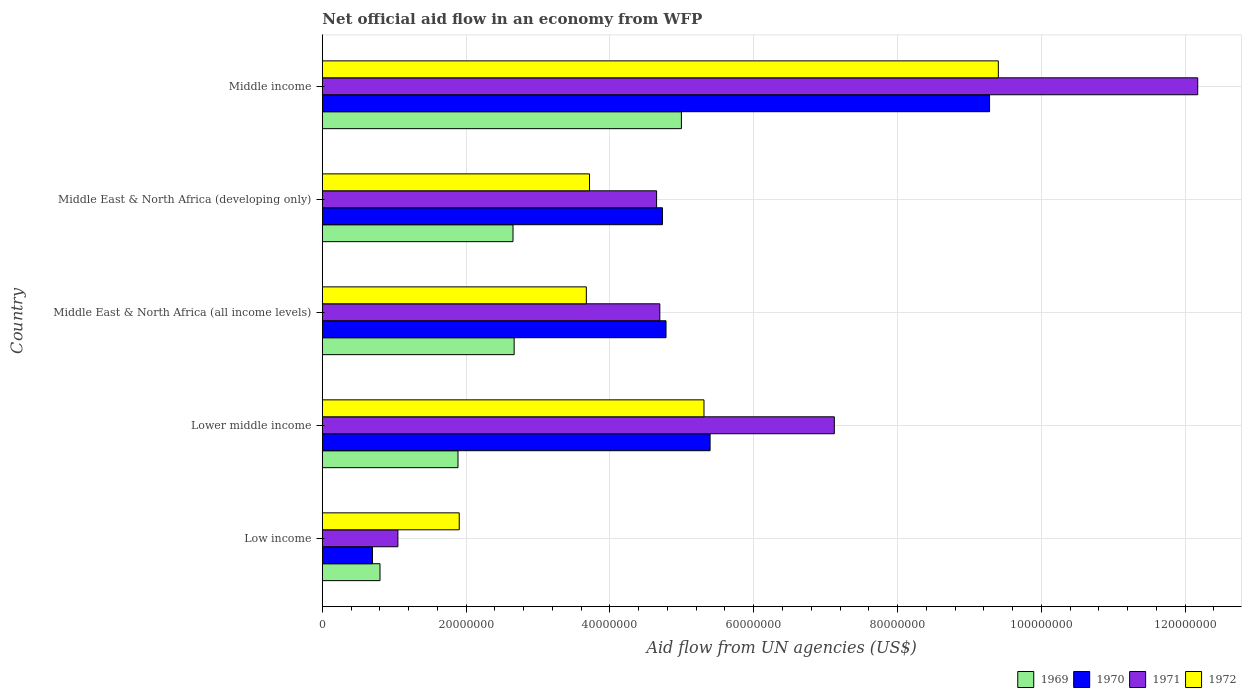How many different coloured bars are there?
Ensure brevity in your answer.  4. Are the number of bars per tick equal to the number of legend labels?
Your response must be concise. Yes. Are the number of bars on each tick of the Y-axis equal?
Provide a short and direct response. Yes. How many bars are there on the 5th tick from the top?
Make the answer very short. 4. How many bars are there on the 4th tick from the bottom?
Give a very brief answer. 4. What is the label of the 1st group of bars from the top?
Your response must be concise. Middle income. In how many cases, is the number of bars for a given country not equal to the number of legend labels?
Keep it short and to the point. 0. What is the net official aid flow in 1972 in Middle income?
Your answer should be compact. 9.40e+07. Across all countries, what is the maximum net official aid flow in 1972?
Give a very brief answer. 9.40e+07. Across all countries, what is the minimum net official aid flow in 1972?
Your answer should be compact. 1.90e+07. In which country was the net official aid flow in 1971 maximum?
Your response must be concise. Middle income. What is the total net official aid flow in 1971 in the graph?
Give a very brief answer. 2.97e+08. What is the difference between the net official aid flow in 1970 in Middle East & North Africa (all income levels) and that in Middle income?
Provide a short and direct response. -4.50e+07. What is the difference between the net official aid flow in 1969 in Middle East & North Africa (all income levels) and the net official aid flow in 1972 in Low income?
Your answer should be compact. 7.64e+06. What is the average net official aid flow in 1969 per country?
Ensure brevity in your answer.  2.60e+07. What is the difference between the net official aid flow in 1971 and net official aid flow in 1972 in Middle East & North Africa (developing only)?
Your answer should be very brief. 9.33e+06. What is the ratio of the net official aid flow in 1971 in Middle East & North Africa (all income levels) to that in Middle income?
Keep it short and to the point. 0.39. Is the net official aid flow in 1972 in Low income less than that in Middle income?
Provide a short and direct response. Yes. Is the difference between the net official aid flow in 1971 in Lower middle income and Middle East & North Africa (all income levels) greater than the difference between the net official aid flow in 1972 in Lower middle income and Middle East & North Africa (all income levels)?
Offer a terse response. Yes. What is the difference between the highest and the second highest net official aid flow in 1972?
Your answer should be compact. 4.09e+07. What is the difference between the highest and the lowest net official aid flow in 1971?
Provide a short and direct response. 1.11e+08. Is it the case that in every country, the sum of the net official aid flow in 1969 and net official aid flow in 1972 is greater than the sum of net official aid flow in 1971 and net official aid flow in 1970?
Offer a very short reply. No. How many bars are there?
Your answer should be compact. 20. What is the difference between two consecutive major ticks on the X-axis?
Give a very brief answer. 2.00e+07. Does the graph contain any zero values?
Give a very brief answer. No. Where does the legend appear in the graph?
Make the answer very short. Bottom right. How are the legend labels stacked?
Provide a short and direct response. Horizontal. What is the title of the graph?
Your answer should be very brief. Net official aid flow in an economy from WFP. What is the label or title of the X-axis?
Offer a very short reply. Aid flow from UN agencies (US$). What is the Aid flow from UN agencies (US$) of 1969 in Low income?
Your answer should be compact. 8.02e+06. What is the Aid flow from UN agencies (US$) in 1970 in Low income?
Your answer should be very brief. 6.97e+06. What is the Aid flow from UN agencies (US$) of 1971 in Low income?
Ensure brevity in your answer.  1.05e+07. What is the Aid flow from UN agencies (US$) of 1972 in Low income?
Keep it short and to the point. 1.90e+07. What is the Aid flow from UN agencies (US$) in 1969 in Lower middle income?
Give a very brief answer. 1.89e+07. What is the Aid flow from UN agencies (US$) in 1970 in Lower middle income?
Your answer should be very brief. 5.39e+07. What is the Aid flow from UN agencies (US$) in 1971 in Lower middle income?
Your answer should be compact. 7.12e+07. What is the Aid flow from UN agencies (US$) of 1972 in Lower middle income?
Offer a terse response. 5.31e+07. What is the Aid flow from UN agencies (US$) in 1969 in Middle East & North Africa (all income levels)?
Offer a terse response. 2.67e+07. What is the Aid flow from UN agencies (US$) in 1970 in Middle East & North Africa (all income levels)?
Make the answer very short. 4.78e+07. What is the Aid flow from UN agencies (US$) of 1971 in Middle East & North Africa (all income levels)?
Keep it short and to the point. 4.69e+07. What is the Aid flow from UN agencies (US$) of 1972 in Middle East & North Africa (all income levels)?
Keep it short and to the point. 3.67e+07. What is the Aid flow from UN agencies (US$) of 1969 in Middle East & North Africa (developing only)?
Your answer should be compact. 2.65e+07. What is the Aid flow from UN agencies (US$) of 1970 in Middle East & North Africa (developing only)?
Offer a terse response. 4.73e+07. What is the Aid flow from UN agencies (US$) in 1971 in Middle East & North Africa (developing only)?
Make the answer very short. 4.65e+07. What is the Aid flow from UN agencies (US$) in 1972 in Middle East & North Africa (developing only)?
Ensure brevity in your answer.  3.72e+07. What is the Aid flow from UN agencies (US$) in 1969 in Middle income?
Ensure brevity in your answer.  4.99e+07. What is the Aid flow from UN agencies (US$) in 1970 in Middle income?
Your response must be concise. 9.28e+07. What is the Aid flow from UN agencies (US$) of 1971 in Middle income?
Provide a succinct answer. 1.22e+08. What is the Aid flow from UN agencies (US$) of 1972 in Middle income?
Make the answer very short. 9.40e+07. Across all countries, what is the maximum Aid flow from UN agencies (US$) of 1969?
Your answer should be very brief. 4.99e+07. Across all countries, what is the maximum Aid flow from UN agencies (US$) in 1970?
Offer a very short reply. 9.28e+07. Across all countries, what is the maximum Aid flow from UN agencies (US$) in 1971?
Make the answer very short. 1.22e+08. Across all countries, what is the maximum Aid flow from UN agencies (US$) of 1972?
Offer a very short reply. 9.40e+07. Across all countries, what is the minimum Aid flow from UN agencies (US$) in 1969?
Your answer should be compact. 8.02e+06. Across all countries, what is the minimum Aid flow from UN agencies (US$) of 1970?
Your answer should be compact. 6.97e+06. Across all countries, what is the minimum Aid flow from UN agencies (US$) in 1971?
Provide a succinct answer. 1.05e+07. Across all countries, what is the minimum Aid flow from UN agencies (US$) in 1972?
Your response must be concise. 1.90e+07. What is the total Aid flow from UN agencies (US$) of 1969 in the graph?
Provide a succinct answer. 1.30e+08. What is the total Aid flow from UN agencies (US$) in 1970 in the graph?
Keep it short and to the point. 2.49e+08. What is the total Aid flow from UN agencies (US$) in 1971 in the graph?
Your answer should be compact. 2.97e+08. What is the total Aid flow from UN agencies (US$) of 1972 in the graph?
Provide a short and direct response. 2.40e+08. What is the difference between the Aid flow from UN agencies (US$) in 1969 in Low income and that in Lower middle income?
Give a very brief answer. -1.08e+07. What is the difference between the Aid flow from UN agencies (US$) of 1970 in Low income and that in Lower middle income?
Make the answer very short. -4.70e+07. What is the difference between the Aid flow from UN agencies (US$) of 1971 in Low income and that in Lower middle income?
Ensure brevity in your answer.  -6.07e+07. What is the difference between the Aid flow from UN agencies (US$) in 1972 in Low income and that in Lower middle income?
Your response must be concise. -3.40e+07. What is the difference between the Aid flow from UN agencies (US$) of 1969 in Low income and that in Middle East & North Africa (all income levels)?
Keep it short and to the point. -1.87e+07. What is the difference between the Aid flow from UN agencies (US$) in 1970 in Low income and that in Middle East & North Africa (all income levels)?
Give a very brief answer. -4.08e+07. What is the difference between the Aid flow from UN agencies (US$) of 1971 in Low income and that in Middle East & North Africa (all income levels)?
Your answer should be very brief. -3.64e+07. What is the difference between the Aid flow from UN agencies (US$) in 1972 in Low income and that in Middle East & North Africa (all income levels)?
Provide a succinct answer. -1.77e+07. What is the difference between the Aid flow from UN agencies (US$) in 1969 in Low income and that in Middle East & North Africa (developing only)?
Make the answer very short. -1.85e+07. What is the difference between the Aid flow from UN agencies (US$) of 1970 in Low income and that in Middle East & North Africa (developing only)?
Your answer should be very brief. -4.03e+07. What is the difference between the Aid flow from UN agencies (US$) of 1971 in Low income and that in Middle East & North Africa (developing only)?
Provide a succinct answer. -3.60e+07. What is the difference between the Aid flow from UN agencies (US$) of 1972 in Low income and that in Middle East & North Africa (developing only)?
Your answer should be very brief. -1.81e+07. What is the difference between the Aid flow from UN agencies (US$) in 1969 in Low income and that in Middle income?
Your answer should be very brief. -4.19e+07. What is the difference between the Aid flow from UN agencies (US$) in 1970 in Low income and that in Middle income?
Ensure brevity in your answer.  -8.58e+07. What is the difference between the Aid flow from UN agencies (US$) of 1971 in Low income and that in Middle income?
Offer a terse response. -1.11e+08. What is the difference between the Aid flow from UN agencies (US$) in 1972 in Low income and that in Middle income?
Provide a succinct answer. -7.50e+07. What is the difference between the Aid flow from UN agencies (US$) in 1969 in Lower middle income and that in Middle East & North Africa (all income levels)?
Offer a terse response. -7.81e+06. What is the difference between the Aid flow from UN agencies (US$) in 1970 in Lower middle income and that in Middle East & North Africa (all income levels)?
Your response must be concise. 6.13e+06. What is the difference between the Aid flow from UN agencies (US$) of 1971 in Lower middle income and that in Middle East & North Africa (all income levels)?
Your answer should be very brief. 2.43e+07. What is the difference between the Aid flow from UN agencies (US$) of 1972 in Lower middle income and that in Middle East & North Africa (all income levels)?
Provide a short and direct response. 1.64e+07. What is the difference between the Aid flow from UN agencies (US$) in 1969 in Lower middle income and that in Middle East & North Africa (developing only)?
Give a very brief answer. -7.65e+06. What is the difference between the Aid flow from UN agencies (US$) in 1970 in Lower middle income and that in Middle East & North Africa (developing only)?
Keep it short and to the point. 6.63e+06. What is the difference between the Aid flow from UN agencies (US$) in 1971 in Lower middle income and that in Middle East & North Africa (developing only)?
Offer a very short reply. 2.47e+07. What is the difference between the Aid flow from UN agencies (US$) in 1972 in Lower middle income and that in Middle East & North Africa (developing only)?
Ensure brevity in your answer.  1.59e+07. What is the difference between the Aid flow from UN agencies (US$) of 1969 in Lower middle income and that in Middle income?
Give a very brief answer. -3.11e+07. What is the difference between the Aid flow from UN agencies (US$) in 1970 in Lower middle income and that in Middle income?
Your answer should be very brief. -3.89e+07. What is the difference between the Aid flow from UN agencies (US$) in 1971 in Lower middle income and that in Middle income?
Make the answer very short. -5.05e+07. What is the difference between the Aid flow from UN agencies (US$) of 1972 in Lower middle income and that in Middle income?
Keep it short and to the point. -4.09e+07. What is the difference between the Aid flow from UN agencies (US$) of 1972 in Middle East & North Africa (all income levels) and that in Middle East & North Africa (developing only)?
Your answer should be compact. -4.40e+05. What is the difference between the Aid flow from UN agencies (US$) of 1969 in Middle East & North Africa (all income levels) and that in Middle income?
Keep it short and to the point. -2.33e+07. What is the difference between the Aid flow from UN agencies (US$) in 1970 in Middle East & North Africa (all income levels) and that in Middle income?
Provide a succinct answer. -4.50e+07. What is the difference between the Aid flow from UN agencies (US$) in 1971 in Middle East & North Africa (all income levels) and that in Middle income?
Your answer should be very brief. -7.48e+07. What is the difference between the Aid flow from UN agencies (US$) in 1972 in Middle East & North Africa (all income levels) and that in Middle income?
Keep it short and to the point. -5.73e+07. What is the difference between the Aid flow from UN agencies (US$) of 1969 in Middle East & North Africa (developing only) and that in Middle income?
Provide a succinct answer. -2.34e+07. What is the difference between the Aid flow from UN agencies (US$) in 1970 in Middle East & North Africa (developing only) and that in Middle income?
Your response must be concise. -4.55e+07. What is the difference between the Aid flow from UN agencies (US$) in 1971 in Middle East & North Africa (developing only) and that in Middle income?
Your response must be concise. -7.53e+07. What is the difference between the Aid flow from UN agencies (US$) of 1972 in Middle East & North Africa (developing only) and that in Middle income?
Ensure brevity in your answer.  -5.69e+07. What is the difference between the Aid flow from UN agencies (US$) in 1969 in Low income and the Aid flow from UN agencies (US$) in 1970 in Lower middle income?
Your response must be concise. -4.59e+07. What is the difference between the Aid flow from UN agencies (US$) of 1969 in Low income and the Aid flow from UN agencies (US$) of 1971 in Lower middle income?
Ensure brevity in your answer.  -6.32e+07. What is the difference between the Aid flow from UN agencies (US$) in 1969 in Low income and the Aid flow from UN agencies (US$) in 1972 in Lower middle income?
Offer a terse response. -4.51e+07. What is the difference between the Aid flow from UN agencies (US$) of 1970 in Low income and the Aid flow from UN agencies (US$) of 1971 in Lower middle income?
Offer a very short reply. -6.42e+07. What is the difference between the Aid flow from UN agencies (US$) of 1970 in Low income and the Aid flow from UN agencies (US$) of 1972 in Lower middle income?
Make the answer very short. -4.61e+07. What is the difference between the Aid flow from UN agencies (US$) of 1971 in Low income and the Aid flow from UN agencies (US$) of 1972 in Lower middle income?
Offer a terse response. -4.26e+07. What is the difference between the Aid flow from UN agencies (US$) of 1969 in Low income and the Aid flow from UN agencies (US$) of 1970 in Middle East & North Africa (all income levels)?
Keep it short and to the point. -3.98e+07. What is the difference between the Aid flow from UN agencies (US$) in 1969 in Low income and the Aid flow from UN agencies (US$) in 1971 in Middle East & North Africa (all income levels)?
Offer a very short reply. -3.89e+07. What is the difference between the Aid flow from UN agencies (US$) of 1969 in Low income and the Aid flow from UN agencies (US$) of 1972 in Middle East & North Africa (all income levels)?
Your answer should be very brief. -2.87e+07. What is the difference between the Aid flow from UN agencies (US$) of 1970 in Low income and the Aid flow from UN agencies (US$) of 1971 in Middle East & North Africa (all income levels)?
Provide a short and direct response. -4.00e+07. What is the difference between the Aid flow from UN agencies (US$) in 1970 in Low income and the Aid flow from UN agencies (US$) in 1972 in Middle East & North Africa (all income levels)?
Provide a succinct answer. -2.98e+07. What is the difference between the Aid flow from UN agencies (US$) in 1971 in Low income and the Aid flow from UN agencies (US$) in 1972 in Middle East & North Africa (all income levels)?
Give a very brief answer. -2.62e+07. What is the difference between the Aid flow from UN agencies (US$) in 1969 in Low income and the Aid flow from UN agencies (US$) in 1970 in Middle East & North Africa (developing only)?
Ensure brevity in your answer.  -3.93e+07. What is the difference between the Aid flow from UN agencies (US$) in 1969 in Low income and the Aid flow from UN agencies (US$) in 1971 in Middle East & North Africa (developing only)?
Keep it short and to the point. -3.85e+07. What is the difference between the Aid flow from UN agencies (US$) in 1969 in Low income and the Aid flow from UN agencies (US$) in 1972 in Middle East & North Africa (developing only)?
Offer a very short reply. -2.91e+07. What is the difference between the Aid flow from UN agencies (US$) in 1970 in Low income and the Aid flow from UN agencies (US$) in 1971 in Middle East & North Africa (developing only)?
Your response must be concise. -3.95e+07. What is the difference between the Aid flow from UN agencies (US$) of 1970 in Low income and the Aid flow from UN agencies (US$) of 1972 in Middle East & North Africa (developing only)?
Provide a succinct answer. -3.02e+07. What is the difference between the Aid flow from UN agencies (US$) of 1971 in Low income and the Aid flow from UN agencies (US$) of 1972 in Middle East & North Africa (developing only)?
Ensure brevity in your answer.  -2.66e+07. What is the difference between the Aid flow from UN agencies (US$) of 1969 in Low income and the Aid flow from UN agencies (US$) of 1970 in Middle income?
Offer a very short reply. -8.48e+07. What is the difference between the Aid flow from UN agencies (US$) of 1969 in Low income and the Aid flow from UN agencies (US$) of 1971 in Middle income?
Your answer should be very brief. -1.14e+08. What is the difference between the Aid flow from UN agencies (US$) of 1969 in Low income and the Aid flow from UN agencies (US$) of 1972 in Middle income?
Make the answer very short. -8.60e+07. What is the difference between the Aid flow from UN agencies (US$) in 1970 in Low income and the Aid flow from UN agencies (US$) in 1971 in Middle income?
Offer a terse response. -1.15e+08. What is the difference between the Aid flow from UN agencies (US$) of 1970 in Low income and the Aid flow from UN agencies (US$) of 1972 in Middle income?
Your answer should be very brief. -8.70e+07. What is the difference between the Aid flow from UN agencies (US$) in 1971 in Low income and the Aid flow from UN agencies (US$) in 1972 in Middle income?
Offer a terse response. -8.35e+07. What is the difference between the Aid flow from UN agencies (US$) of 1969 in Lower middle income and the Aid flow from UN agencies (US$) of 1970 in Middle East & North Africa (all income levels)?
Offer a terse response. -2.89e+07. What is the difference between the Aid flow from UN agencies (US$) of 1969 in Lower middle income and the Aid flow from UN agencies (US$) of 1971 in Middle East & North Africa (all income levels)?
Provide a short and direct response. -2.81e+07. What is the difference between the Aid flow from UN agencies (US$) of 1969 in Lower middle income and the Aid flow from UN agencies (US$) of 1972 in Middle East & North Africa (all income levels)?
Keep it short and to the point. -1.78e+07. What is the difference between the Aid flow from UN agencies (US$) in 1970 in Lower middle income and the Aid flow from UN agencies (US$) in 1971 in Middle East & North Africa (all income levels)?
Your answer should be very brief. 6.99e+06. What is the difference between the Aid flow from UN agencies (US$) of 1970 in Lower middle income and the Aid flow from UN agencies (US$) of 1972 in Middle East & North Africa (all income levels)?
Offer a very short reply. 1.72e+07. What is the difference between the Aid flow from UN agencies (US$) of 1971 in Lower middle income and the Aid flow from UN agencies (US$) of 1972 in Middle East & North Africa (all income levels)?
Offer a very short reply. 3.45e+07. What is the difference between the Aid flow from UN agencies (US$) in 1969 in Lower middle income and the Aid flow from UN agencies (US$) in 1970 in Middle East & North Africa (developing only)?
Your answer should be compact. -2.84e+07. What is the difference between the Aid flow from UN agencies (US$) in 1969 in Lower middle income and the Aid flow from UN agencies (US$) in 1971 in Middle East & North Africa (developing only)?
Ensure brevity in your answer.  -2.76e+07. What is the difference between the Aid flow from UN agencies (US$) in 1969 in Lower middle income and the Aid flow from UN agencies (US$) in 1972 in Middle East & North Africa (developing only)?
Your response must be concise. -1.83e+07. What is the difference between the Aid flow from UN agencies (US$) in 1970 in Lower middle income and the Aid flow from UN agencies (US$) in 1971 in Middle East & North Africa (developing only)?
Your answer should be compact. 7.44e+06. What is the difference between the Aid flow from UN agencies (US$) of 1970 in Lower middle income and the Aid flow from UN agencies (US$) of 1972 in Middle East & North Africa (developing only)?
Keep it short and to the point. 1.68e+07. What is the difference between the Aid flow from UN agencies (US$) in 1971 in Lower middle income and the Aid flow from UN agencies (US$) in 1972 in Middle East & North Africa (developing only)?
Ensure brevity in your answer.  3.40e+07. What is the difference between the Aid flow from UN agencies (US$) of 1969 in Lower middle income and the Aid flow from UN agencies (US$) of 1970 in Middle income?
Ensure brevity in your answer.  -7.39e+07. What is the difference between the Aid flow from UN agencies (US$) of 1969 in Lower middle income and the Aid flow from UN agencies (US$) of 1971 in Middle income?
Ensure brevity in your answer.  -1.03e+08. What is the difference between the Aid flow from UN agencies (US$) in 1969 in Lower middle income and the Aid flow from UN agencies (US$) in 1972 in Middle income?
Keep it short and to the point. -7.52e+07. What is the difference between the Aid flow from UN agencies (US$) of 1970 in Lower middle income and the Aid flow from UN agencies (US$) of 1971 in Middle income?
Provide a short and direct response. -6.78e+07. What is the difference between the Aid flow from UN agencies (US$) of 1970 in Lower middle income and the Aid flow from UN agencies (US$) of 1972 in Middle income?
Offer a very short reply. -4.01e+07. What is the difference between the Aid flow from UN agencies (US$) of 1971 in Lower middle income and the Aid flow from UN agencies (US$) of 1972 in Middle income?
Offer a very short reply. -2.28e+07. What is the difference between the Aid flow from UN agencies (US$) of 1969 in Middle East & North Africa (all income levels) and the Aid flow from UN agencies (US$) of 1970 in Middle East & North Africa (developing only)?
Your answer should be very brief. -2.06e+07. What is the difference between the Aid flow from UN agencies (US$) of 1969 in Middle East & North Africa (all income levels) and the Aid flow from UN agencies (US$) of 1971 in Middle East & North Africa (developing only)?
Keep it short and to the point. -1.98e+07. What is the difference between the Aid flow from UN agencies (US$) of 1969 in Middle East & North Africa (all income levels) and the Aid flow from UN agencies (US$) of 1972 in Middle East & North Africa (developing only)?
Your answer should be very brief. -1.05e+07. What is the difference between the Aid flow from UN agencies (US$) of 1970 in Middle East & North Africa (all income levels) and the Aid flow from UN agencies (US$) of 1971 in Middle East & North Africa (developing only)?
Make the answer very short. 1.31e+06. What is the difference between the Aid flow from UN agencies (US$) of 1970 in Middle East & North Africa (all income levels) and the Aid flow from UN agencies (US$) of 1972 in Middle East & North Africa (developing only)?
Offer a very short reply. 1.06e+07. What is the difference between the Aid flow from UN agencies (US$) of 1971 in Middle East & North Africa (all income levels) and the Aid flow from UN agencies (US$) of 1972 in Middle East & North Africa (developing only)?
Your response must be concise. 9.78e+06. What is the difference between the Aid flow from UN agencies (US$) of 1969 in Middle East & North Africa (all income levels) and the Aid flow from UN agencies (US$) of 1970 in Middle income?
Your answer should be very brief. -6.61e+07. What is the difference between the Aid flow from UN agencies (US$) in 1969 in Middle East & North Africa (all income levels) and the Aid flow from UN agencies (US$) in 1971 in Middle income?
Keep it short and to the point. -9.51e+07. What is the difference between the Aid flow from UN agencies (US$) in 1969 in Middle East & North Africa (all income levels) and the Aid flow from UN agencies (US$) in 1972 in Middle income?
Keep it short and to the point. -6.73e+07. What is the difference between the Aid flow from UN agencies (US$) in 1970 in Middle East & North Africa (all income levels) and the Aid flow from UN agencies (US$) in 1971 in Middle income?
Ensure brevity in your answer.  -7.40e+07. What is the difference between the Aid flow from UN agencies (US$) of 1970 in Middle East & North Africa (all income levels) and the Aid flow from UN agencies (US$) of 1972 in Middle income?
Provide a short and direct response. -4.62e+07. What is the difference between the Aid flow from UN agencies (US$) in 1971 in Middle East & North Africa (all income levels) and the Aid flow from UN agencies (US$) in 1972 in Middle income?
Provide a succinct answer. -4.71e+07. What is the difference between the Aid flow from UN agencies (US$) in 1969 in Middle East & North Africa (developing only) and the Aid flow from UN agencies (US$) in 1970 in Middle income?
Keep it short and to the point. -6.63e+07. What is the difference between the Aid flow from UN agencies (US$) in 1969 in Middle East & North Africa (developing only) and the Aid flow from UN agencies (US$) in 1971 in Middle income?
Your response must be concise. -9.52e+07. What is the difference between the Aid flow from UN agencies (US$) in 1969 in Middle East & North Africa (developing only) and the Aid flow from UN agencies (US$) in 1972 in Middle income?
Offer a very short reply. -6.75e+07. What is the difference between the Aid flow from UN agencies (US$) in 1970 in Middle East & North Africa (developing only) and the Aid flow from UN agencies (US$) in 1971 in Middle income?
Your answer should be very brief. -7.44e+07. What is the difference between the Aid flow from UN agencies (US$) in 1970 in Middle East & North Africa (developing only) and the Aid flow from UN agencies (US$) in 1972 in Middle income?
Make the answer very short. -4.67e+07. What is the difference between the Aid flow from UN agencies (US$) in 1971 in Middle East & North Africa (developing only) and the Aid flow from UN agencies (US$) in 1972 in Middle income?
Your answer should be very brief. -4.75e+07. What is the average Aid flow from UN agencies (US$) in 1969 per country?
Offer a terse response. 2.60e+07. What is the average Aid flow from UN agencies (US$) in 1970 per country?
Keep it short and to the point. 4.98e+07. What is the average Aid flow from UN agencies (US$) in 1971 per country?
Provide a succinct answer. 5.94e+07. What is the average Aid flow from UN agencies (US$) in 1972 per country?
Your response must be concise. 4.80e+07. What is the difference between the Aid flow from UN agencies (US$) of 1969 and Aid flow from UN agencies (US$) of 1970 in Low income?
Your answer should be compact. 1.05e+06. What is the difference between the Aid flow from UN agencies (US$) of 1969 and Aid flow from UN agencies (US$) of 1971 in Low income?
Make the answer very short. -2.49e+06. What is the difference between the Aid flow from UN agencies (US$) in 1969 and Aid flow from UN agencies (US$) in 1972 in Low income?
Make the answer very short. -1.10e+07. What is the difference between the Aid flow from UN agencies (US$) of 1970 and Aid flow from UN agencies (US$) of 1971 in Low income?
Offer a terse response. -3.54e+06. What is the difference between the Aid flow from UN agencies (US$) in 1970 and Aid flow from UN agencies (US$) in 1972 in Low income?
Your response must be concise. -1.21e+07. What is the difference between the Aid flow from UN agencies (US$) in 1971 and Aid flow from UN agencies (US$) in 1972 in Low income?
Your answer should be compact. -8.53e+06. What is the difference between the Aid flow from UN agencies (US$) in 1969 and Aid flow from UN agencies (US$) in 1970 in Lower middle income?
Your answer should be very brief. -3.51e+07. What is the difference between the Aid flow from UN agencies (US$) in 1969 and Aid flow from UN agencies (US$) in 1971 in Lower middle income?
Your answer should be very brief. -5.23e+07. What is the difference between the Aid flow from UN agencies (US$) of 1969 and Aid flow from UN agencies (US$) of 1972 in Lower middle income?
Make the answer very short. -3.42e+07. What is the difference between the Aid flow from UN agencies (US$) in 1970 and Aid flow from UN agencies (US$) in 1971 in Lower middle income?
Offer a very short reply. -1.73e+07. What is the difference between the Aid flow from UN agencies (US$) in 1970 and Aid flow from UN agencies (US$) in 1972 in Lower middle income?
Give a very brief answer. 8.50e+05. What is the difference between the Aid flow from UN agencies (US$) of 1971 and Aid flow from UN agencies (US$) of 1972 in Lower middle income?
Keep it short and to the point. 1.81e+07. What is the difference between the Aid flow from UN agencies (US$) in 1969 and Aid flow from UN agencies (US$) in 1970 in Middle East & North Africa (all income levels)?
Offer a very short reply. -2.11e+07. What is the difference between the Aid flow from UN agencies (US$) of 1969 and Aid flow from UN agencies (US$) of 1971 in Middle East & North Africa (all income levels)?
Your answer should be very brief. -2.03e+07. What is the difference between the Aid flow from UN agencies (US$) of 1969 and Aid flow from UN agencies (US$) of 1972 in Middle East & North Africa (all income levels)?
Provide a short and direct response. -1.00e+07. What is the difference between the Aid flow from UN agencies (US$) in 1970 and Aid flow from UN agencies (US$) in 1971 in Middle East & North Africa (all income levels)?
Provide a succinct answer. 8.60e+05. What is the difference between the Aid flow from UN agencies (US$) in 1970 and Aid flow from UN agencies (US$) in 1972 in Middle East & North Africa (all income levels)?
Offer a very short reply. 1.11e+07. What is the difference between the Aid flow from UN agencies (US$) in 1971 and Aid flow from UN agencies (US$) in 1972 in Middle East & North Africa (all income levels)?
Provide a succinct answer. 1.02e+07. What is the difference between the Aid flow from UN agencies (US$) in 1969 and Aid flow from UN agencies (US$) in 1970 in Middle East & North Africa (developing only)?
Your response must be concise. -2.08e+07. What is the difference between the Aid flow from UN agencies (US$) of 1969 and Aid flow from UN agencies (US$) of 1971 in Middle East & North Africa (developing only)?
Give a very brief answer. -2.00e+07. What is the difference between the Aid flow from UN agencies (US$) in 1969 and Aid flow from UN agencies (US$) in 1972 in Middle East & North Africa (developing only)?
Keep it short and to the point. -1.06e+07. What is the difference between the Aid flow from UN agencies (US$) in 1970 and Aid flow from UN agencies (US$) in 1971 in Middle East & North Africa (developing only)?
Keep it short and to the point. 8.10e+05. What is the difference between the Aid flow from UN agencies (US$) in 1970 and Aid flow from UN agencies (US$) in 1972 in Middle East & North Africa (developing only)?
Your response must be concise. 1.01e+07. What is the difference between the Aid flow from UN agencies (US$) of 1971 and Aid flow from UN agencies (US$) of 1972 in Middle East & North Africa (developing only)?
Offer a terse response. 9.33e+06. What is the difference between the Aid flow from UN agencies (US$) of 1969 and Aid flow from UN agencies (US$) of 1970 in Middle income?
Offer a terse response. -4.29e+07. What is the difference between the Aid flow from UN agencies (US$) of 1969 and Aid flow from UN agencies (US$) of 1971 in Middle income?
Offer a terse response. -7.18e+07. What is the difference between the Aid flow from UN agencies (US$) in 1969 and Aid flow from UN agencies (US$) in 1972 in Middle income?
Your response must be concise. -4.41e+07. What is the difference between the Aid flow from UN agencies (US$) in 1970 and Aid flow from UN agencies (US$) in 1971 in Middle income?
Your answer should be compact. -2.90e+07. What is the difference between the Aid flow from UN agencies (US$) in 1970 and Aid flow from UN agencies (US$) in 1972 in Middle income?
Ensure brevity in your answer.  -1.22e+06. What is the difference between the Aid flow from UN agencies (US$) in 1971 and Aid flow from UN agencies (US$) in 1972 in Middle income?
Make the answer very short. 2.77e+07. What is the ratio of the Aid flow from UN agencies (US$) of 1969 in Low income to that in Lower middle income?
Provide a short and direct response. 0.42. What is the ratio of the Aid flow from UN agencies (US$) in 1970 in Low income to that in Lower middle income?
Make the answer very short. 0.13. What is the ratio of the Aid flow from UN agencies (US$) of 1971 in Low income to that in Lower middle income?
Make the answer very short. 0.15. What is the ratio of the Aid flow from UN agencies (US$) in 1972 in Low income to that in Lower middle income?
Your answer should be compact. 0.36. What is the ratio of the Aid flow from UN agencies (US$) in 1969 in Low income to that in Middle East & North Africa (all income levels)?
Your answer should be compact. 0.3. What is the ratio of the Aid flow from UN agencies (US$) of 1970 in Low income to that in Middle East & North Africa (all income levels)?
Your answer should be compact. 0.15. What is the ratio of the Aid flow from UN agencies (US$) of 1971 in Low income to that in Middle East & North Africa (all income levels)?
Provide a succinct answer. 0.22. What is the ratio of the Aid flow from UN agencies (US$) in 1972 in Low income to that in Middle East & North Africa (all income levels)?
Make the answer very short. 0.52. What is the ratio of the Aid flow from UN agencies (US$) in 1969 in Low income to that in Middle East & North Africa (developing only)?
Your response must be concise. 0.3. What is the ratio of the Aid flow from UN agencies (US$) of 1970 in Low income to that in Middle East & North Africa (developing only)?
Make the answer very short. 0.15. What is the ratio of the Aid flow from UN agencies (US$) in 1971 in Low income to that in Middle East & North Africa (developing only)?
Make the answer very short. 0.23. What is the ratio of the Aid flow from UN agencies (US$) of 1972 in Low income to that in Middle East & North Africa (developing only)?
Offer a terse response. 0.51. What is the ratio of the Aid flow from UN agencies (US$) of 1969 in Low income to that in Middle income?
Offer a terse response. 0.16. What is the ratio of the Aid flow from UN agencies (US$) of 1970 in Low income to that in Middle income?
Make the answer very short. 0.08. What is the ratio of the Aid flow from UN agencies (US$) of 1971 in Low income to that in Middle income?
Make the answer very short. 0.09. What is the ratio of the Aid flow from UN agencies (US$) of 1972 in Low income to that in Middle income?
Your answer should be very brief. 0.2. What is the ratio of the Aid flow from UN agencies (US$) in 1969 in Lower middle income to that in Middle East & North Africa (all income levels)?
Provide a succinct answer. 0.71. What is the ratio of the Aid flow from UN agencies (US$) in 1970 in Lower middle income to that in Middle East & North Africa (all income levels)?
Offer a terse response. 1.13. What is the ratio of the Aid flow from UN agencies (US$) in 1971 in Lower middle income to that in Middle East & North Africa (all income levels)?
Your answer should be very brief. 1.52. What is the ratio of the Aid flow from UN agencies (US$) in 1972 in Lower middle income to that in Middle East & North Africa (all income levels)?
Keep it short and to the point. 1.45. What is the ratio of the Aid flow from UN agencies (US$) in 1969 in Lower middle income to that in Middle East & North Africa (developing only)?
Provide a succinct answer. 0.71. What is the ratio of the Aid flow from UN agencies (US$) of 1970 in Lower middle income to that in Middle East & North Africa (developing only)?
Make the answer very short. 1.14. What is the ratio of the Aid flow from UN agencies (US$) in 1971 in Lower middle income to that in Middle East & North Africa (developing only)?
Make the answer very short. 1.53. What is the ratio of the Aid flow from UN agencies (US$) of 1972 in Lower middle income to that in Middle East & North Africa (developing only)?
Keep it short and to the point. 1.43. What is the ratio of the Aid flow from UN agencies (US$) of 1969 in Lower middle income to that in Middle income?
Provide a short and direct response. 0.38. What is the ratio of the Aid flow from UN agencies (US$) of 1970 in Lower middle income to that in Middle income?
Make the answer very short. 0.58. What is the ratio of the Aid flow from UN agencies (US$) in 1971 in Lower middle income to that in Middle income?
Offer a very short reply. 0.58. What is the ratio of the Aid flow from UN agencies (US$) in 1972 in Lower middle income to that in Middle income?
Make the answer very short. 0.56. What is the ratio of the Aid flow from UN agencies (US$) in 1970 in Middle East & North Africa (all income levels) to that in Middle East & North Africa (developing only)?
Offer a very short reply. 1.01. What is the ratio of the Aid flow from UN agencies (US$) of 1971 in Middle East & North Africa (all income levels) to that in Middle East & North Africa (developing only)?
Make the answer very short. 1.01. What is the ratio of the Aid flow from UN agencies (US$) of 1972 in Middle East & North Africa (all income levels) to that in Middle East & North Africa (developing only)?
Offer a very short reply. 0.99. What is the ratio of the Aid flow from UN agencies (US$) of 1969 in Middle East & North Africa (all income levels) to that in Middle income?
Your response must be concise. 0.53. What is the ratio of the Aid flow from UN agencies (US$) of 1970 in Middle East & North Africa (all income levels) to that in Middle income?
Ensure brevity in your answer.  0.52. What is the ratio of the Aid flow from UN agencies (US$) of 1971 in Middle East & North Africa (all income levels) to that in Middle income?
Provide a short and direct response. 0.39. What is the ratio of the Aid flow from UN agencies (US$) in 1972 in Middle East & North Africa (all income levels) to that in Middle income?
Offer a terse response. 0.39. What is the ratio of the Aid flow from UN agencies (US$) in 1969 in Middle East & North Africa (developing only) to that in Middle income?
Make the answer very short. 0.53. What is the ratio of the Aid flow from UN agencies (US$) of 1970 in Middle East & North Africa (developing only) to that in Middle income?
Your answer should be very brief. 0.51. What is the ratio of the Aid flow from UN agencies (US$) of 1971 in Middle East & North Africa (developing only) to that in Middle income?
Keep it short and to the point. 0.38. What is the ratio of the Aid flow from UN agencies (US$) in 1972 in Middle East & North Africa (developing only) to that in Middle income?
Provide a short and direct response. 0.4. What is the difference between the highest and the second highest Aid flow from UN agencies (US$) in 1969?
Provide a succinct answer. 2.33e+07. What is the difference between the highest and the second highest Aid flow from UN agencies (US$) in 1970?
Offer a very short reply. 3.89e+07. What is the difference between the highest and the second highest Aid flow from UN agencies (US$) in 1971?
Offer a very short reply. 5.05e+07. What is the difference between the highest and the second highest Aid flow from UN agencies (US$) in 1972?
Offer a terse response. 4.09e+07. What is the difference between the highest and the lowest Aid flow from UN agencies (US$) of 1969?
Give a very brief answer. 4.19e+07. What is the difference between the highest and the lowest Aid flow from UN agencies (US$) in 1970?
Your answer should be very brief. 8.58e+07. What is the difference between the highest and the lowest Aid flow from UN agencies (US$) in 1971?
Your answer should be very brief. 1.11e+08. What is the difference between the highest and the lowest Aid flow from UN agencies (US$) of 1972?
Your answer should be very brief. 7.50e+07. 